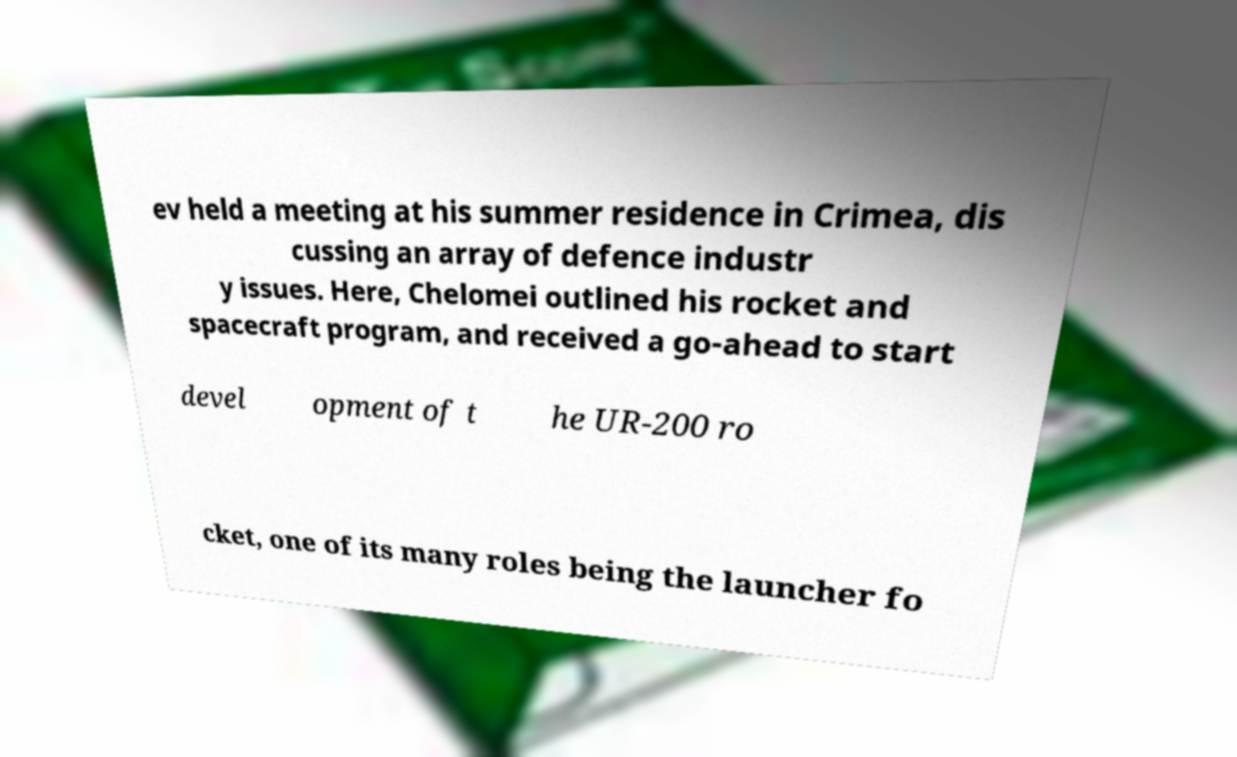What messages or text are displayed in this image? I need them in a readable, typed format. ev held a meeting at his summer residence in Crimea, dis cussing an array of defence industr y issues. Here, Chelomei outlined his rocket and spacecraft program, and received a go-ahead to start devel opment of t he UR-200 ro cket, one of its many roles being the launcher fo 